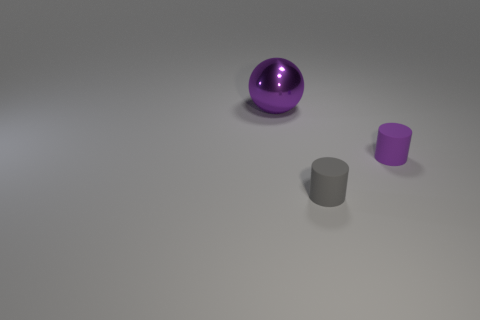How many objects are either things that are in front of the purple shiny object or yellow metallic spheres?
Your answer should be compact. 2. Is the tiny gray cylinder made of the same material as the object left of the small gray matte object?
Provide a succinct answer. No. What number of other objects are there of the same shape as the gray rubber object?
Offer a terse response. 1. How many objects are things that are on the right side of the gray rubber cylinder or small purple things behind the tiny gray rubber object?
Provide a succinct answer. 1. How many other objects are there of the same color as the large thing?
Provide a short and direct response. 1. Are there fewer cylinders behind the small purple matte object than purple things right of the large purple ball?
Your answer should be compact. Yes. How many tiny blue things are there?
Your response must be concise. 0. Is there any other thing that is the same material as the large sphere?
Offer a very short reply. No. Is the number of purple objects behind the purple rubber object less than the number of tiny matte things?
Provide a succinct answer. Yes. Does the purple thing that is in front of the purple shiny sphere have the same shape as the gray matte thing?
Your answer should be compact. Yes. 